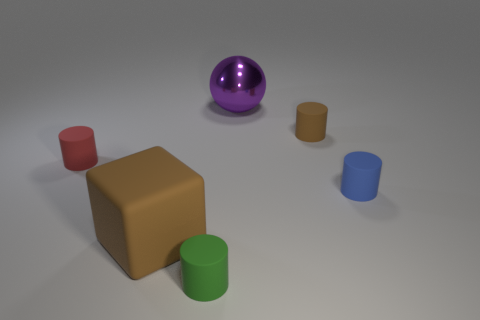How many objects are either tiny objects in front of the red cylinder or objects right of the big ball?
Offer a terse response. 3. Is the size of the red rubber object the same as the sphere?
Give a very brief answer. No. Is the number of big purple metal objects greater than the number of large gray blocks?
Provide a short and direct response. Yes. What number of other things are there of the same color as the large rubber thing?
Your response must be concise. 1. What number of things are either blue things or large rubber blocks?
Offer a terse response. 2. Is the shape of the brown object to the right of the green cylinder the same as  the green object?
Keep it short and to the point. Yes. The large thing that is behind the tiny rubber cylinder that is left of the brown block is what color?
Offer a very short reply. Purple. Is the number of large purple things less than the number of brown objects?
Offer a very short reply. Yes. Is there a small purple cylinder made of the same material as the small red cylinder?
Offer a terse response. No. There is a big purple thing; is its shape the same as the brown rubber thing to the left of the big metal sphere?
Ensure brevity in your answer.  No. 